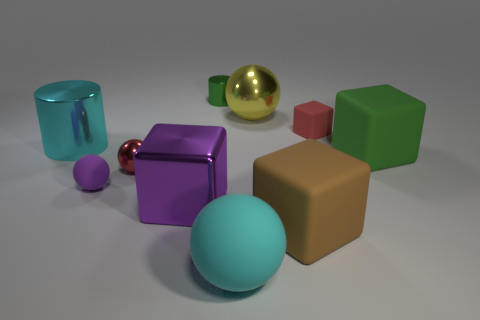What color is the cube that is right of the green cylinder and on the left side of the tiny red rubber block?
Provide a succinct answer. Brown. Does the red object to the left of the large matte ball have the same material as the brown cube?
Your answer should be very brief. No. Are there fewer large yellow things on the left side of the big brown object than cylinders?
Give a very brief answer. Yes. Are there any purple cubes that have the same material as the big cyan cylinder?
Give a very brief answer. Yes. There is a green rubber thing; is its size the same as the shiny cylinder in front of the big metal sphere?
Provide a short and direct response. Yes. Are there any metal cylinders that have the same color as the metallic block?
Give a very brief answer. No. Is the material of the yellow object the same as the small green cylinder?
Your response must be concise. Yes. There is a big brown rubber cube; what number of metal things are to the left of it?
Your answer should be compact. 5. What material is the tiny object that is in front of the big cyan cylinder and on the right side of the tiny purple thing?
Make the answer very short. Metal. What number of red cubes are the same size as the green rubber block?
Your answer should be very brief. 0. 